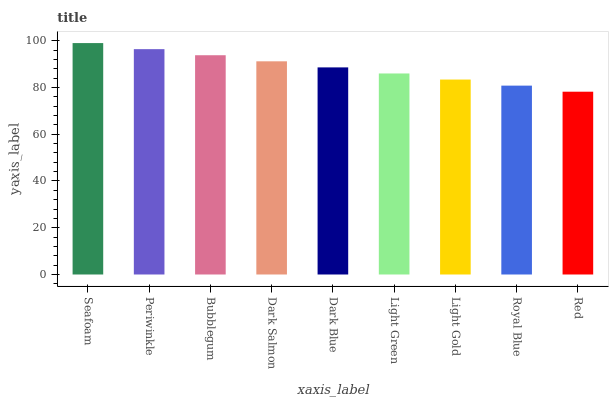Is Periwinkle the minimum?
Answer yes or no. No. Is Periwinkle the maximum?
Answer yes or no. No. Is Seafoam greater than Periwinkle?
Answer yes or no. Yes. Is Periwinkle less than Seafoam?
Answer yes or no. Yes. Is Periwinkle greater than Seafoam?
Answer yes or no. No. Is Seafoam less than Periwinkle?
Answer yes or no. No. Is Dark Blue the high median?
Answer yes or no. Yes. Is Dark Blue the low median?
Answer yes or no. Yes. Is Dark Salmon the high median?
Answer yes or no. No. Is Dark Salmon the low median?
Answer yes or no. No. 